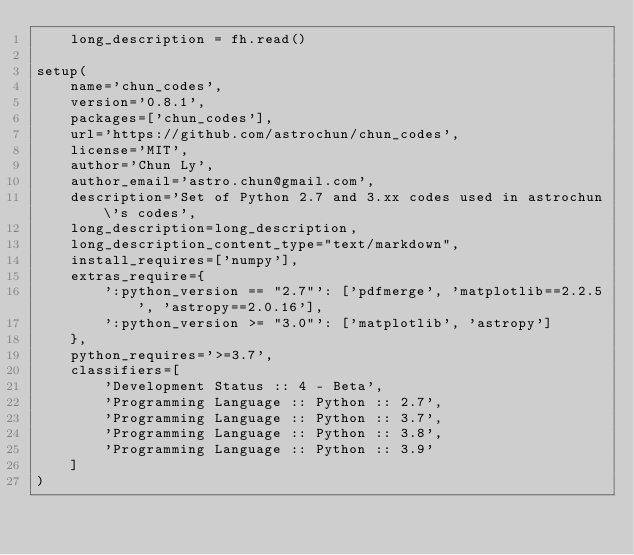Convert code to text. <code><loc_0><loc_0><loc_500><loc_500><_Python_>    long_description = fh.read()

setup(
    name='chun_codes',
    version='0.8.1',
    packages=['chun_codes'],
    url='https://github.com/astrochun/chun_codes',
    license='MIT',
    author='Chun Ly',
    author_email='astro.chun@gmail.com',
    description='Set of Python 2.7 and 3.xx codes used in astrochun\'s codes',
    long_description=long_description,
    long_description_content_type="text/markdown",
    install_requires=['numpy'],
    extras_require={
        ':python_version == "2.7"': ['pdfmerge', 'matplotlib==2.2.5', 'astropy==2.0.16'],
        ':python_version >= "3.0"': ['matplotlib', 'astropy']
    },
    python_requires='>=3.7',
    classifiers=[
        'Development Status :: 4 - Beta',
        'Programming Language :: Python :: 2.7',
        'Programming Language :: Python :: 3.7',
        'Programming Language :: Python :: 3.8',
        'Programming Language :: Python :: 3.9'
    ]
)
</code> 